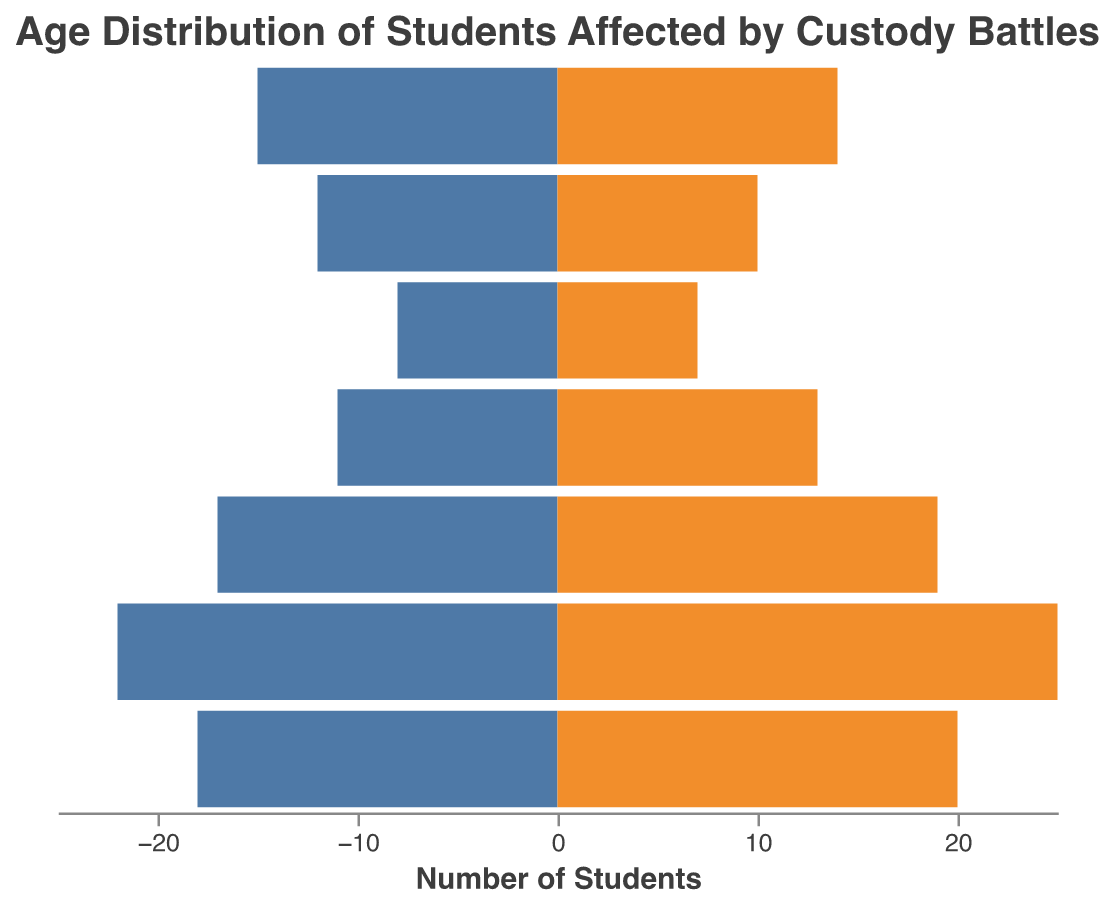What is the title of the plot? The title of the plot is placed at the top and reads "Age Distribution of Students Affected by Custody Battles".
Answer: Age Distribution of Students Affected by Custody Battles What are the age ranges represented in the plot? The age ranges are displayed along the y-axis, sorted in descending order: "17-18", "15-16", "13-14", "11-12", "9-10", "7-8", and "5-6".
Answer: 17-18, 15-16, 13-14, 11-12, 9-10, 7-8, 5-6 Which age range has the highest number of females? Identify the bar that stretches the farthest to the right (representing females). The age range "13-14" has the highest number of females, represented by the longest orange bar.
Answer: 13-14 How many males are in the 9-10 age range? Look at the bar extending to the left for the "9-10" age range. It visually denotes -15 males (since males are plotted as negative values for symmetry in the pyramid).
Answer: 15 What is the total number of students aged 11-12? Add the number of males and females in the "11-12" age group. That is 18 males + 20 females = 38 students.
Answer: 38 Compare the number of males and females aged 15-16. Which group is larger and by how much? Find the values for males and females in the "15-16" age range. Males are 17, and females are 19. Subtract the smaller figure from the larger (19 - 17 = 2). Females are greater by 2.
Answer: Females, by 2 Which age group has the least number of males? Look for the shortest bar on the left side, which represents males. The "5-6" age group has the least number of males with 8.
Answer: 5-6 What is the combined total number of students affected by custody battles in the dataset? Sum the total number of males and females across all age ranges. Males: 8+12+15+18+22+17+11 = 103, Females: 7+10+14+20+25+19+13 = 108. Combined total: 103 + 108 = 211 students.
Answer: 211 Are there more males or females in the age range 7-8, and what's the difference? Compare the lengths of the bars for males and females in the "7-8" group. Males are 12, and females are 10. The difference is 12 - 10 = 2, with more males.
Answer: Males, 2 